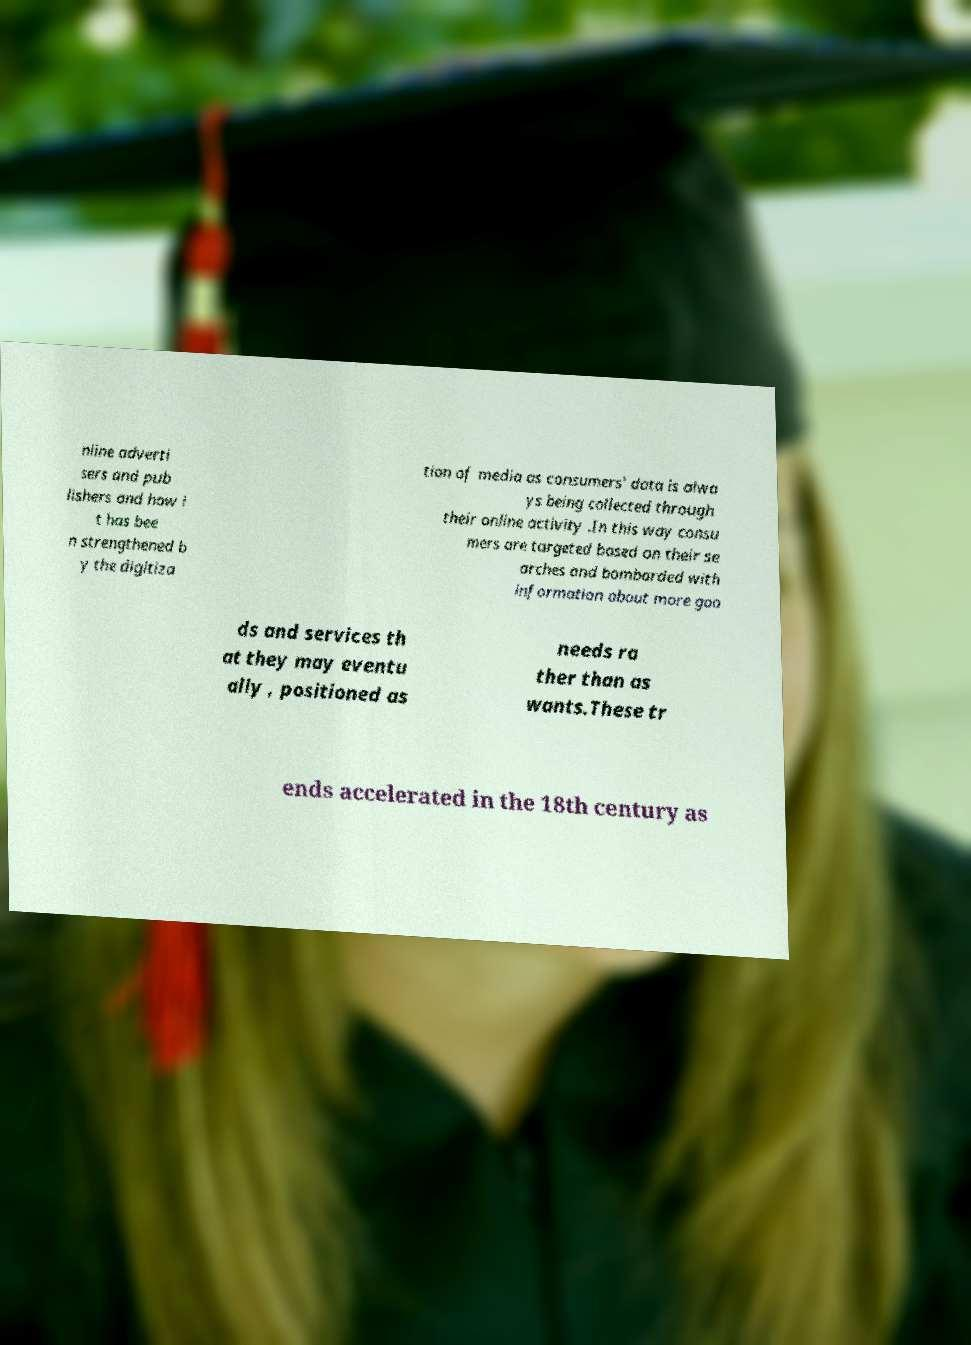Could you extract and type out the text from this image? nline adverti sers and pub lishers and how i t has bee n strengthened b y the digitiza tion of media as consumers' data is alwa ys being collected through their online activity .In this way consu mers are targeted based on their se arches and bombarded with information about more goo ds and services th at they may eventu ally , positioned as needs ra ther than as wants.These tr ends accelerated in the 18th century as 